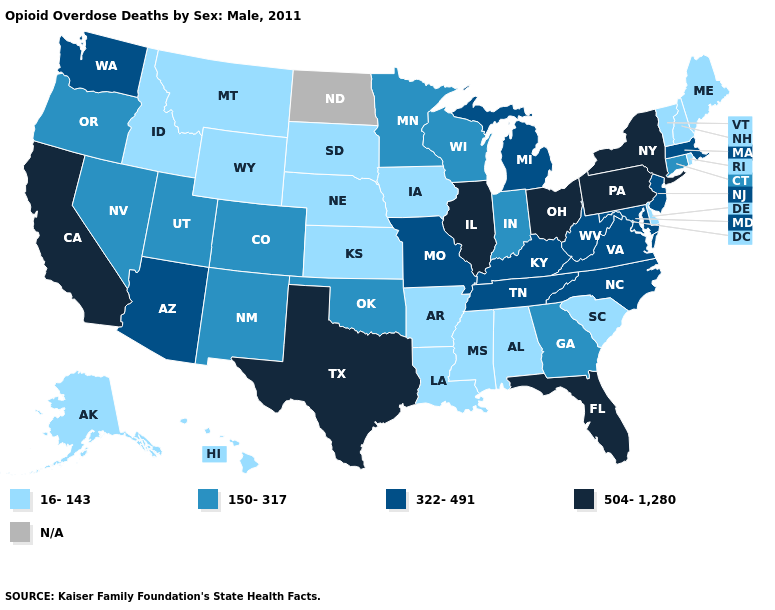What is the value of North Carolina?
Be succinct. 322-491. Does Wyoming have the highest value in the West?
Give a very brief answer. No. Which states have the lowest value in the MidWest?
Answer briefly. Iowa, Kansas, Nebraska, South Dakota. Name the states that have a value in the range 16-143?
Write a very short answer. Alabama, Alaska, Arkansas, Delaware, Hawaii, Idaho, Iowa, Kansas, Louisiana, Maine, Mississippi, Montana, Nebraska, New Hampshire, Rhode Island, South Carolina, South Dakota, Vermont, Wyoming. Name the states that have a value in the range 16-143?
Quick response, please. Alabama, Alaska, Arkansas, Delaware, Hawaii, Idaho, Iowa, Kansas, Louisiana, Maine, Mississippi, Montana, Nebraska, New Hampshire, Rhode Island, South Carolina, South Dakota, Vermont, Wyoming. Among the states that border Nebraska , does Colorado have the highest value?
Give a very brief answer. No. What is the lowest value in the USA?
Concise answer only. 16-143. Name the states that have a value in the range 150-317?
Keep it brief. Colorado, Connecticut, Georgia, Indiana, Minnesota, Nevada, New Mexico, Oklahoma, Oregon, Utah, Wisconsin. What is the value of Louisiana?
Give a very brief answer. 16-143. Which states have the lowest value in the USA?
Keep it brief. Alabama, Alaska, Arkansas, Delaware, Hawaii, Idaho, Iowa, Kansas, Louisiana, Maine, Mississippi, Montana, Nebraska, New Hampshire, Rhode Island, South Carolina, South Dakota, Vermont, Wyoming. What is the highest value in the USA?
Keep it brief. 504-1,280. Name the states that have a value in the range 150-317?
Give a very brief answer. Colorado, Connecticut, Georgia, Indiana, Minnesota, Nevada, New Mexico, Oklahoma, Oregon, Utah, Wisconsin. Name the states that have a value in the range 16-143?
Give a very brief answer. Alabama, Alaska, Arkansas, Delaware, Hawaii, Idaho, Iowa, Kansas, Louisiana, Maine, Mississippi, Montana, Nebraska, New Hampshire, Rhode Island, South Carolina, South Dakota, Vermont, Wyoming. What is the value of Alabama?
Be succinct. 16-143. What is the value of Arizona?
Answer briefly. 322-491. 